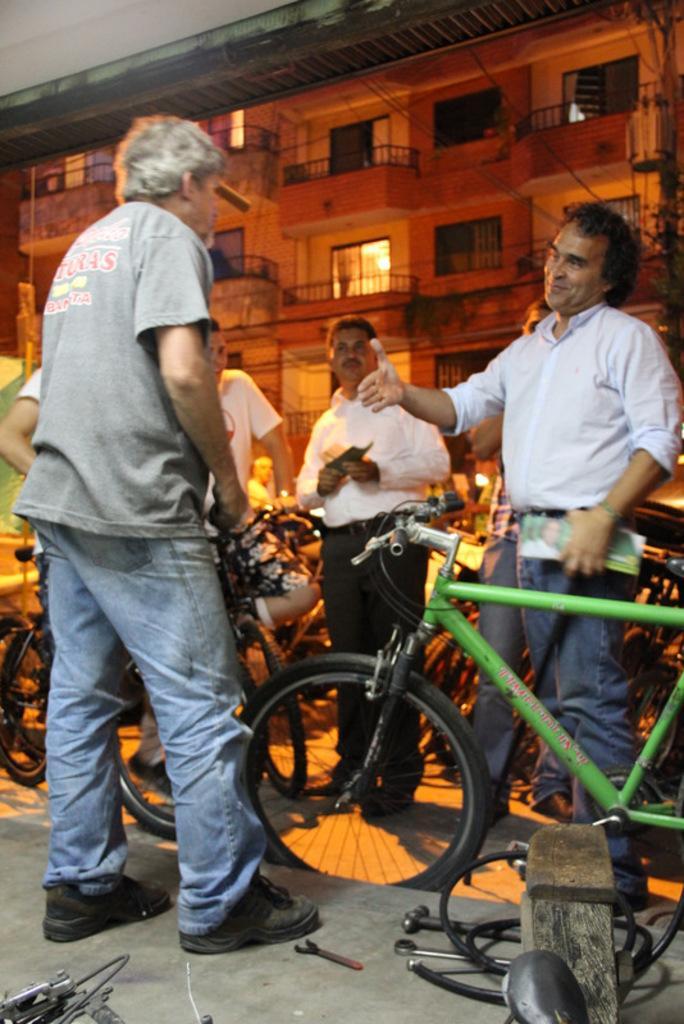How would you summarize this image in a sentence or two? Here we can see four men are standing. There are some bicycles. On the floor there are some tools. In the background there is a building. The man in the right side is smiling. 